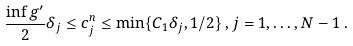<formula> <loc_0><loc_0><loc_500><loc_500>\frac { \inf g ^ { \prime } } 2 \delta _ { j } \leq c ^ { n } _ { j } \leq \min \{ C _ { 1 } \delta _ { j } , 1 / 2 \} \, , j = 1 , \dots , N - 1 \, .</formula> 